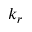<formula> <loc_0><loc_0><loc_500><loc_500>k _ { r }</formula> 